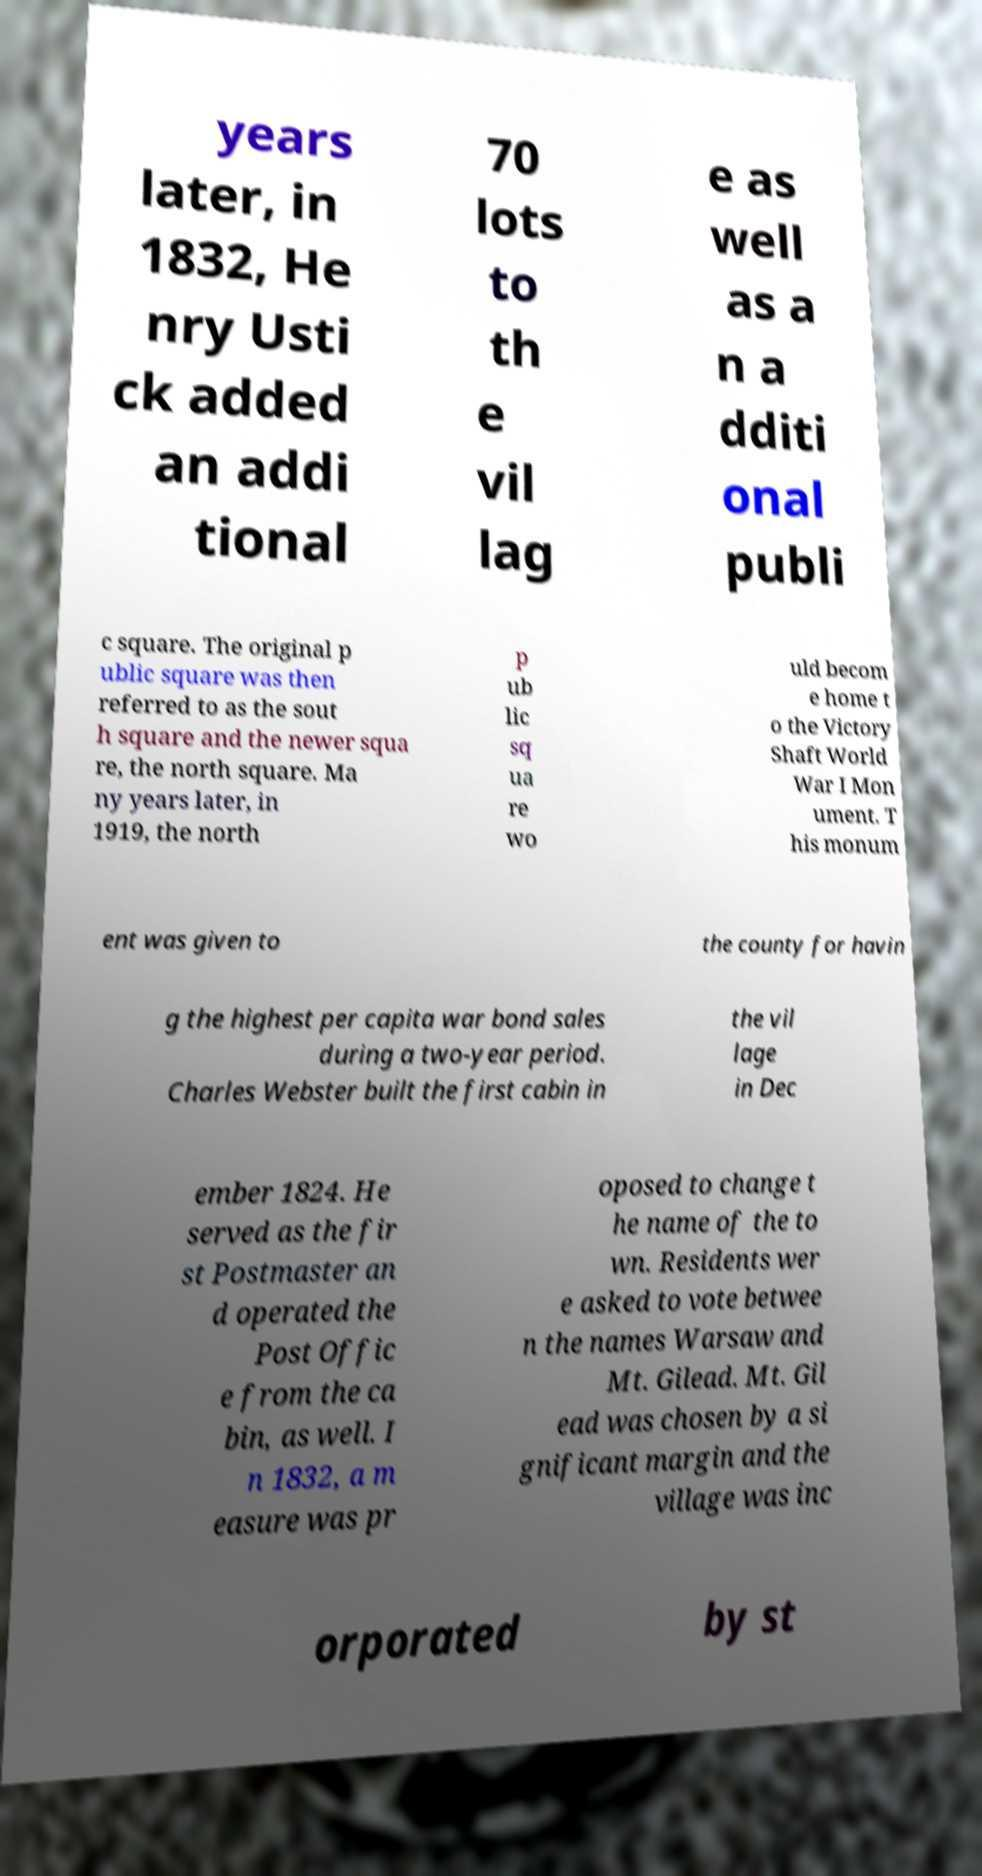There's text embedded in this image that I need extracted. Can you transcribe it verbatim? years later, in 1832, He nry Usti ck added an addi tional 70 lots to th e vil lag e as well as a n a dditi onal publi c square. The original p ublic square was then referred to as the sout h square and the newer squa re, the north square. Ma ny years later, in 1919, the north p ub lic sq ua re wo uld becom e home t o the Victory Shaft World War I Mon ument. T his monum ent was given to the county for havin g the highest per capita war bond sales during a two-year period. Charles Webster built the first cabin in the vil lage in Dec ember 1824. He served as the fir st Postmaster an d operated the Post Offic e from the ca bin, as well. I n 1832, a m easure was pr oposed to change t he name of the to wn. Residents wer e asked to vote betwee n the names Warsaw and Mt. Gilead. Mt. Gil ead was chosen by a si gnificant margin and the village was inc orporated by st 